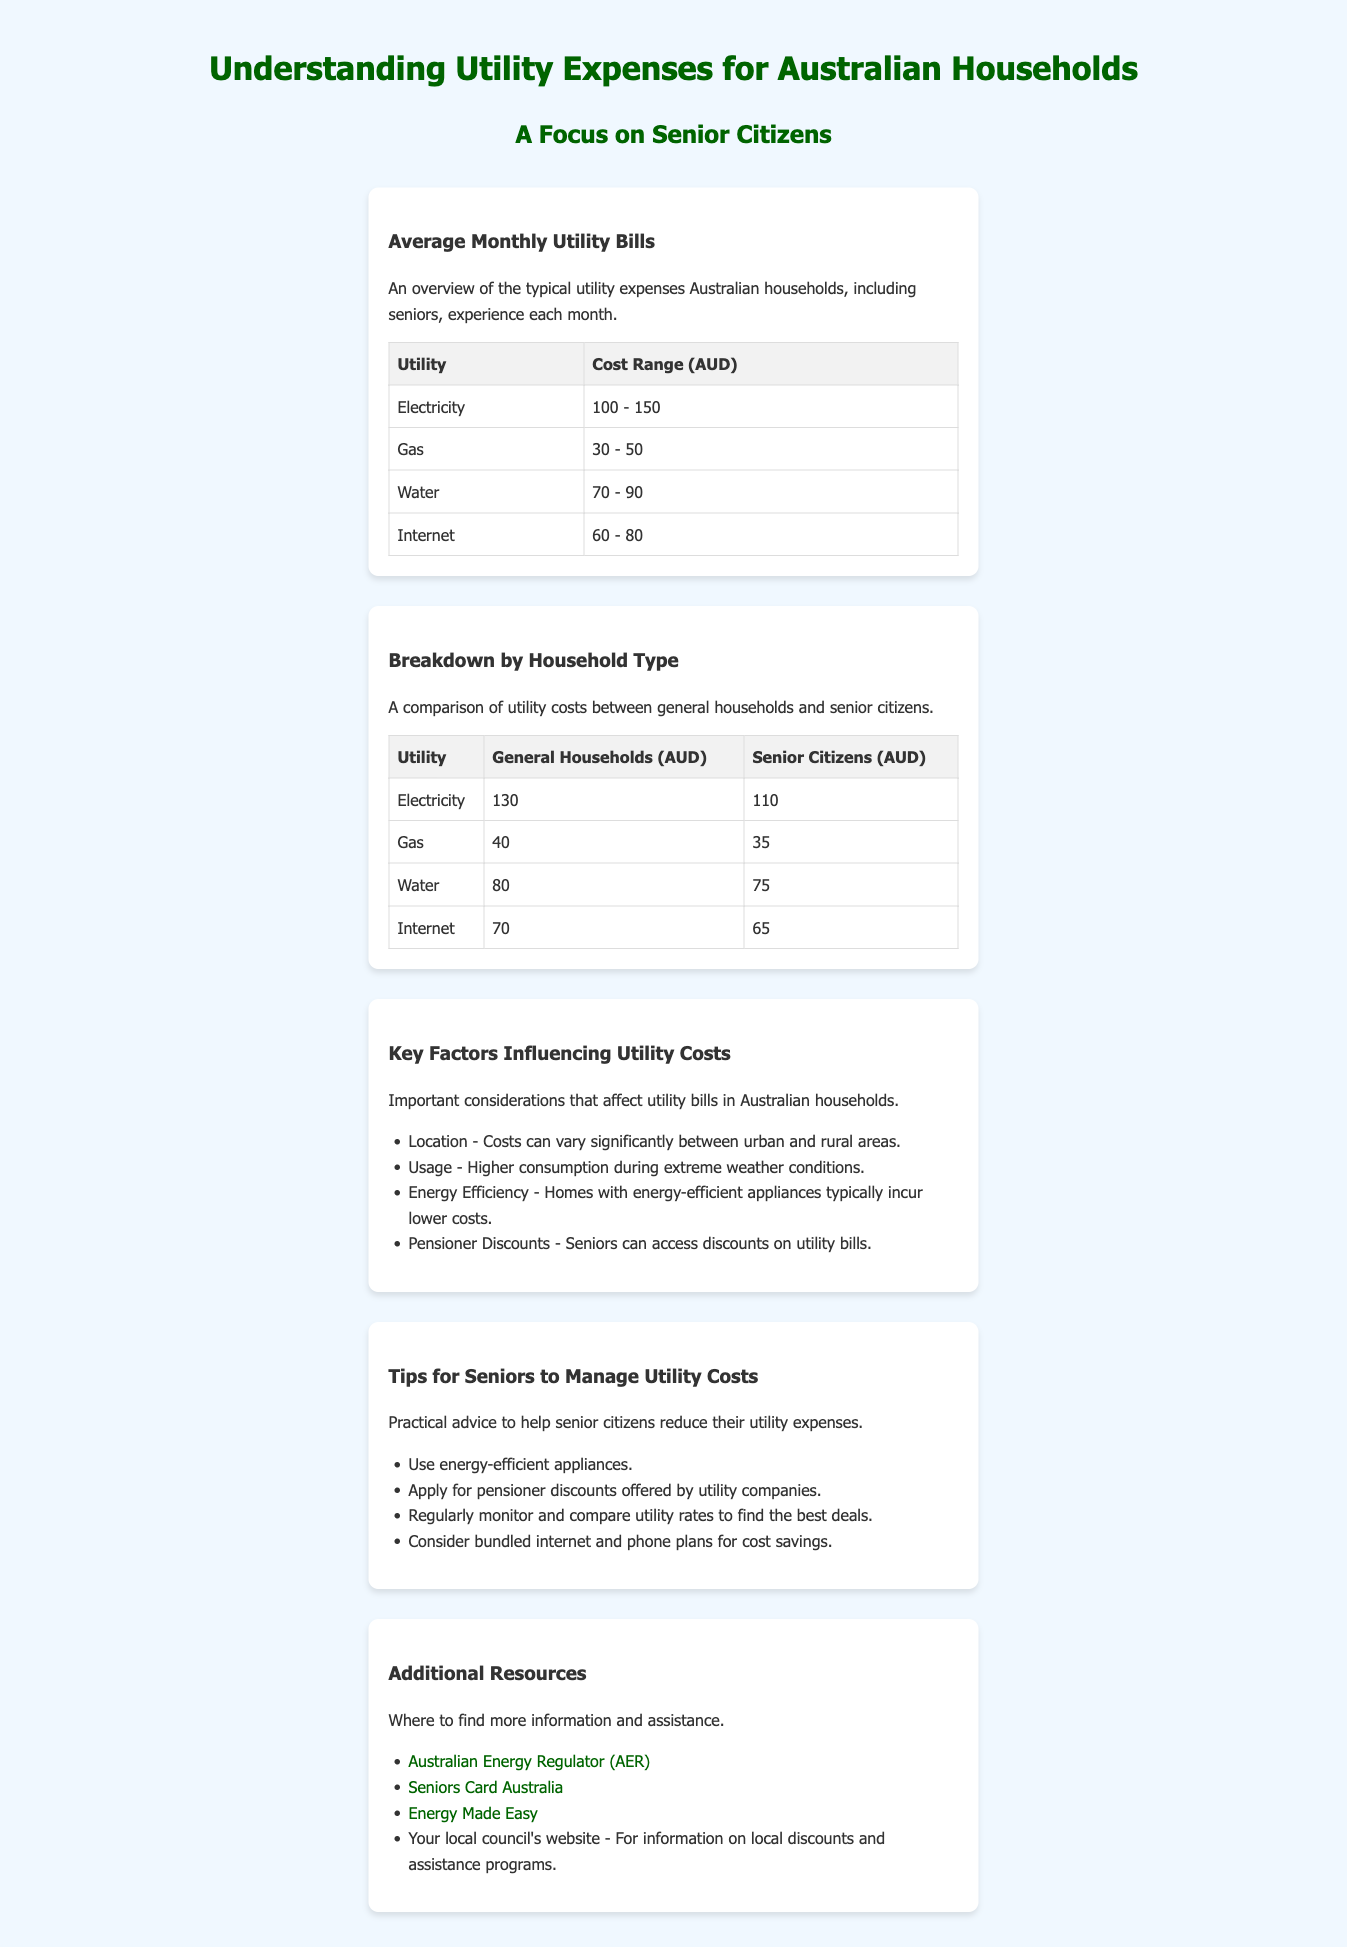What is the average electricity cost for senior citizens? The average electricity cost for senior citizens is derived from the document, which states it is 110 AUD.
Answer: 110 AUD What is the cost range for water utilities? The document lists the cost range for water utilities as 70 - 90 AUD.
Answer: 70 - 90 AUD What percentage lower is the average internet cost for senior citizens compared to general households? The document states that general households pay 70 AUD and seniors pay 65 AUD, thus the average cost for seniors is 5 AUD lower.
Answer: 5 AUD Which utility has the highest cost range listed? The highest cost range in the document is for electricity, which is 100 - 150 AUD.
Answer: Electricity What are two key factors influencing utility costs mentioned in the document? The document highlights location and usage as key factors influencing utility costs.
Answer: Location, Usage What is a practical tip for seniors to manage utility costs? The document suggests using energy-efficient appliances as a practical tip for managing utility costs.
Answer: Use energy-efficient appliances What is the typical cost of gas for general households? The document indicates the typical cost of gas for general households is 40 AUD.
Answer: 40 AUD What organization provides assistance for energy rates in Australia? The Australian Energy Regulator (AER) is mentioned as an organization providing assistance for energy rates.
Answer: Australian Energy Regulator (AER) What is the focus of the infographic? The infographic specifically focuses on the utility expenses of senior citizens in Australian households.
Answer: Senior Citizens 